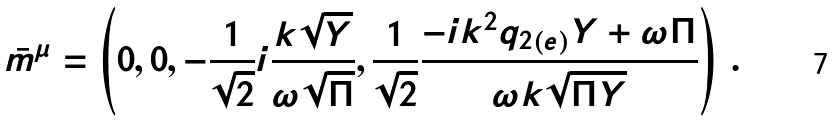Convert formula to latex. <formula><loc_0><loc_0><loc_500><loc_500>\bar { m } ^ { \mu } = \left ( 0 , 0 , - \frac { 1 } { \sqrt { 2 } } i \frac { k \sqrt { Y } } { \omega \sqrt { \Pi } } , \frac { 1 } { \sqrt { 2 } } \frac { - i k ^ { 2 } q _ { 2 ( e ) } Y + \omega \Pi } { \omega k \sqrt { \Pi Y } } \right ) \, .</formula> 